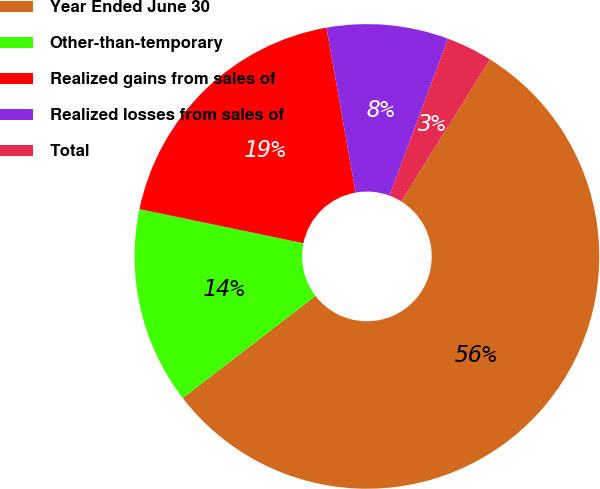<chart> <loc_0><loc_0><loc_500><loc_500><pie_chart><fcel>Year Ended June 30<fcel>Other-than-temporary<fcel>Realized gains from sales of<fcel>Realized losses from sales of<fcel>Total<nl><fcel>55.68%<fcel>13.7%<fcel>18.95%<fcel>8.46%<fcel>3.21%<nl></chart> 